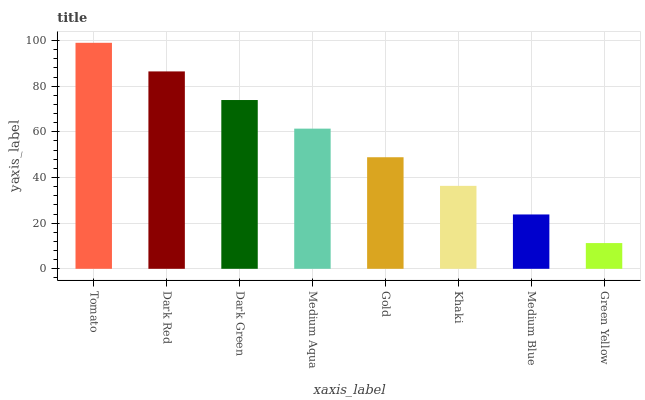Is Green Yellow the minimum?
Answer yes or no. Yes. Is Tomato the maximum?
Answer yes or no. Yes. Is Dark Red the minimum?
Answer yes or no. No. Is Dark Red the maximum?
Answer yes or no. No. Is Tomato greater than Dark Red?
Answer yes or no. Yes. Is Dark Red less than Tomato?
Answer yes or no. Yes. Is Dark Red greater than Tomato?
Answer yes or no. No. Is Tomato less than Dark Red?
Answer yes or no. No. Is Medium Aqua the high median?
Answer yes or no. Yes. Is Gold the low median?
Answer yes or no. Yes. Is Green Yellow the high median?
Answer yes or no. No. Is Tomato the low median?
Answer yes or no. No. 